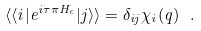<formula> <loc_0><loc_0><loc_500><loc_500>\langle \langle i | e ^ { i \tau \pi H _ { c } } | j \rangle \rangle = \delta _ { i j } \chi _ { i } ( q ) \ .</formula> 